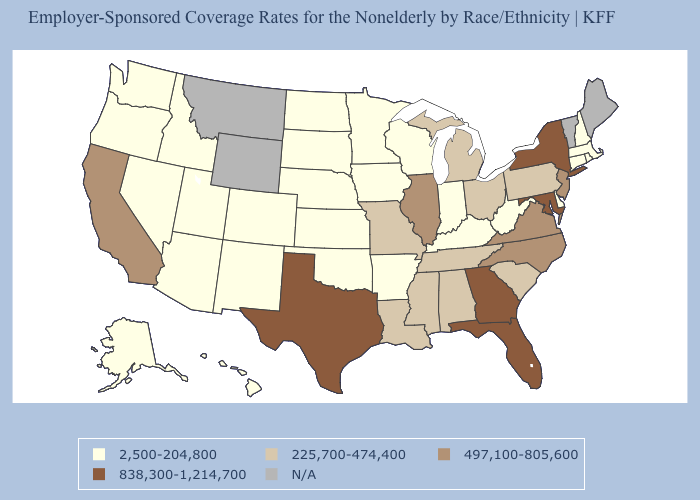Does Maryland have the highest value in the USA?
Keep it brief. Yes. What is the highest value in states that border Texas?
Be succinct. 225,700-474,400. Is the legend a continuous bar?
Be succinct. No. What is the value of Tennessee?
Give a very brief answer. 225,700-474,400. Name the states that have a value in the range 225,700-474,400?
Give a very brief answer. Alabama, Louisiana, Michigan, Mississippi, Missouri, Ohio, Pennsylvania, South Carolina, Tennessee. Name the states that have a value in the range 2,500-204,800?
Write a very short answer. Alaska, Arizona, Arkansas, Colorado, Connecticut, Delaware, Hawaii, Idaho, Indiana, Iowa, Kansas, Kentucky, Massachusetts, Minnesota, Nebraska, Nevada, New Hampshire, New Mexico, North Dakota, Oklahoma, Oregon, Rhode Island, South Dakota, Utah, Washington, West Virginia, Wisconsin. What is the value of Pennsylvania?
Keep it brief. 225,700-474,400. Name the states that have a value in the range 838,300-1,214,700?
Give a very brief answer. Florida, Georgia, Maryland, New York, Texas. What is the highest value in the USA?
Give a very brief answer. 838,300-1,214,700. Among the states that border Maryland , which have the highest value?
Keep it brief. Virginia. How many symbols are there in the legend?
Short answer required. 5. What is the value of Rhode Island?
Keep it brief. 2,500-204,800. What is the lowest value in the USA?
Quick response, please. 2,500-204,800. Does Colorado have the highest value in the West?
Short answer required. No. What is the value of West Virginia?
Answer briefly. 2,500-204,800. 